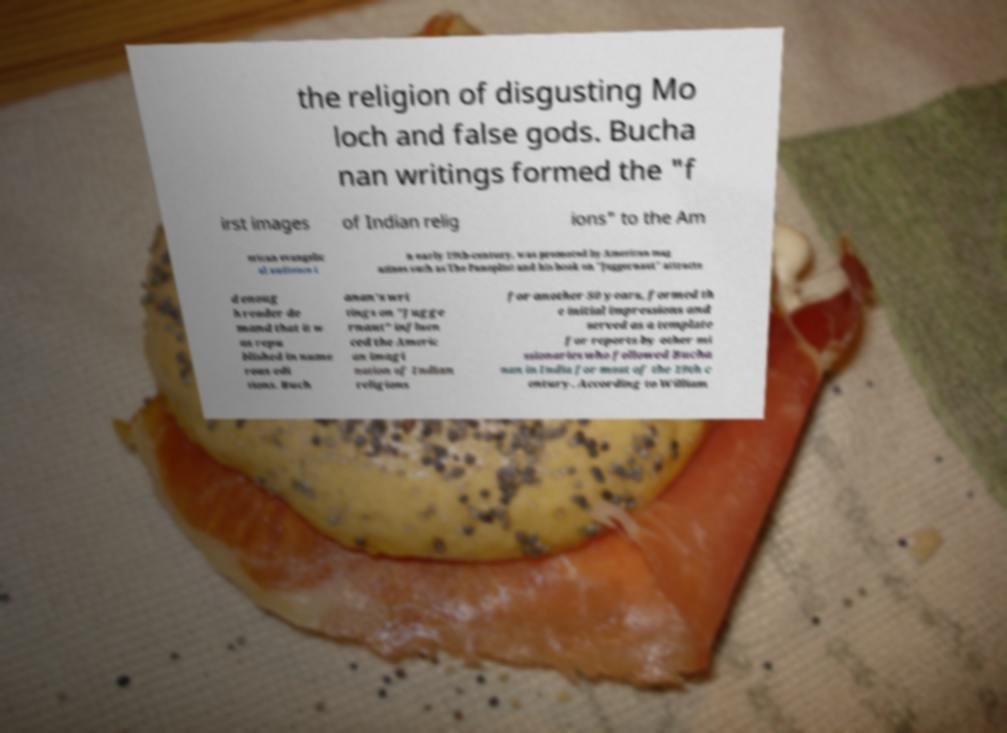There's text embedded in this image that I need extracted. Can you transcribe it verbatim? the religion of disgusting Mo loch and false gods. Bucha nan writings formed the "f irst images of Indian relig ions" to the Am erican evangelic al audience i n early 19th-century, was promoted by American mag azines such as The Panoplist and his book on "Juggernaut" attracte d enoug h reader de mand that it w as repu blished in nume rous edi tions. Buch anan's wri tings on "Jugge rnaut" influen ced the Americ an imagi nation of Indian religions for another 50 years, formed th e initial impressions and served as a template for reports by other mi ssionaries who followed Bucha nan in India for most of the 19th c entury. According to William 